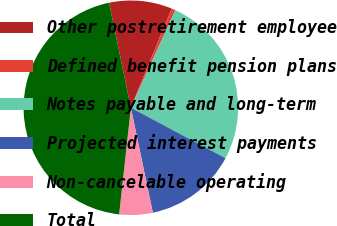Convert chart to OTSL. <chart><loc_0><loc_0><loc_500><loc_500><pie_chart><fcel>Other postretirement employee<fcel>Defined benefit pension plans<fcel>Notes payable and long-term<fcel>Projected interest payments<fcel>Non-cancelable operating<fcel>Total<nl><fcel>9.47%<fcel>0.59%<fcel>25.98%<fcel>13.92%<fcel>5.03%<fcel>45.0%<nl></chart> 